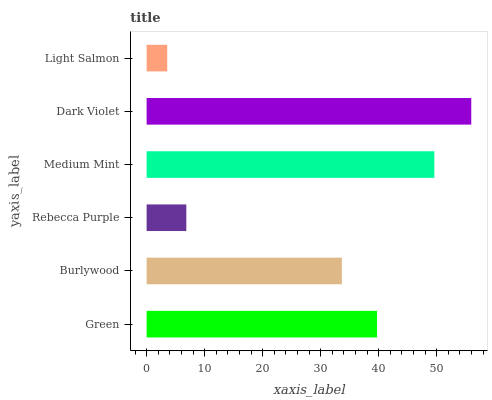Is Light Salmon the minimum?
Answer yes or no. Yes. Is Dark Violet the maximum?
Answer yes or no. Yes. Is Burlywood the minimum?
Answer yes or no. No. Is Burlywood the maximum?
Answer yes or no. No. Is Green greater than Burlywood?
Answer yes or no. Yes. Is Burlywood less than Green?
Answer yes or no. Yes. Is Burlywood greater than Green?
Answer yes or no. No. Is Green less than Burlywood?
Answer yes or no. No. Is Green the high median?
Answer yes or no. Yes. Is Burlywood the low median?
Answer yes or no. Yes. Is Dark Violet the high median?
Answer yes or no. No. Is Green the low median?
Answer yes or no. No. 